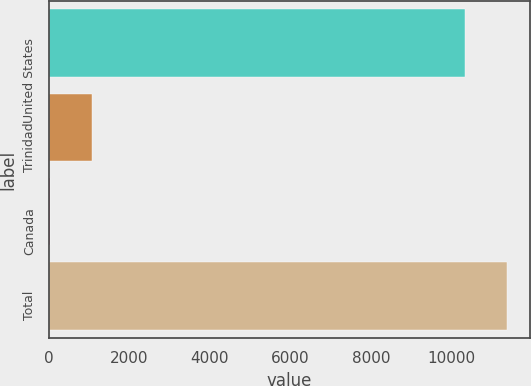Convert chart. <chart><loc_0><loc_0><loc_500><loc_500><bar_chart><fcel>United States<fcel>Trinidad<fcel>Canada<fcel>Total<nl><fcel>10348<fcel>1068.1<fcel>26<fcel>11390.1<nl></chart> 